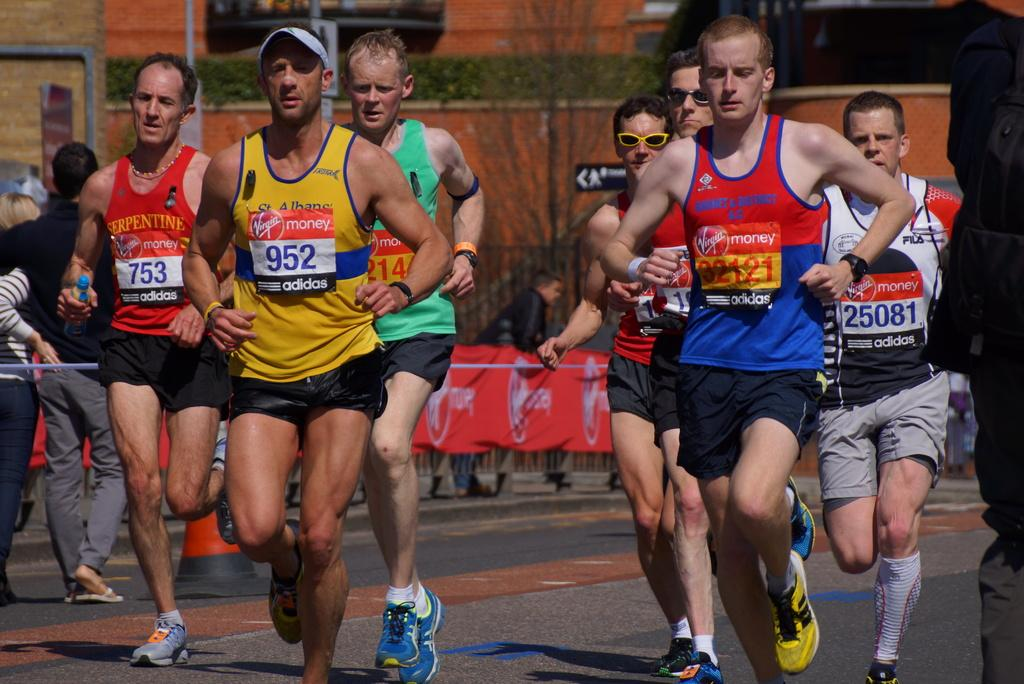<image>
Provide a brief description of the given image. runners in a running race sponsored by Virgin Money and Adidas on the bibs 